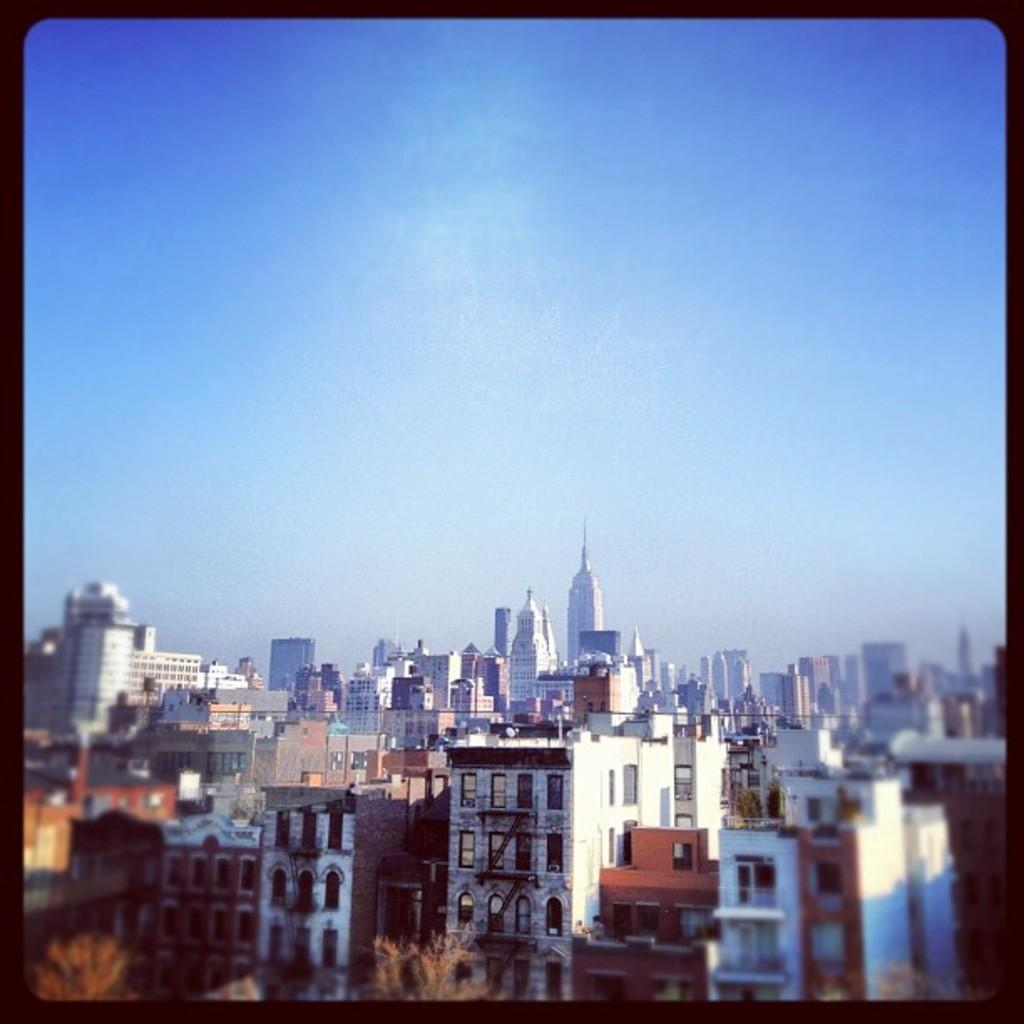What type of structures can be seen in the image? There are buildings in the image. What other natural elements are present in the image? There are trees in the image. What can be seen in the distance in the image? The sky is visible in the background of the image. How many ladybugs can be seen crawling on the buildings in the image? There are no ladybugs present in the image; it features buildings, trees, and the sky. What type of material is the pocket made of in the image? There is no pocket present in the image. 